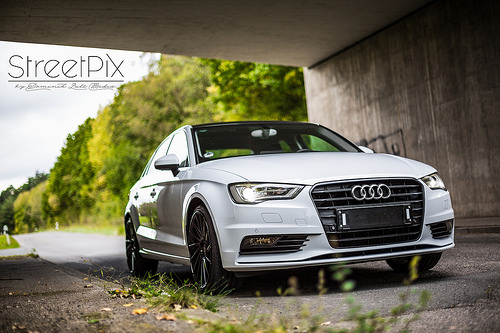<image>
Can you confirm if the logo is to the right of the car? No. The logo is not to the right of the car. The horizontal positioning shows a different relationship. 